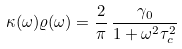<formula> <loc_0><loc_0><loc_500><loc_500>\kappa ( \omega ) \varrho ( \omega ) = \frac { 2 } { \pi } \, \frac { \gamma _ { 0 } } { 1 + \omega ^ { 2 } \tau _ { c } ^ { 2 } }</formula> 